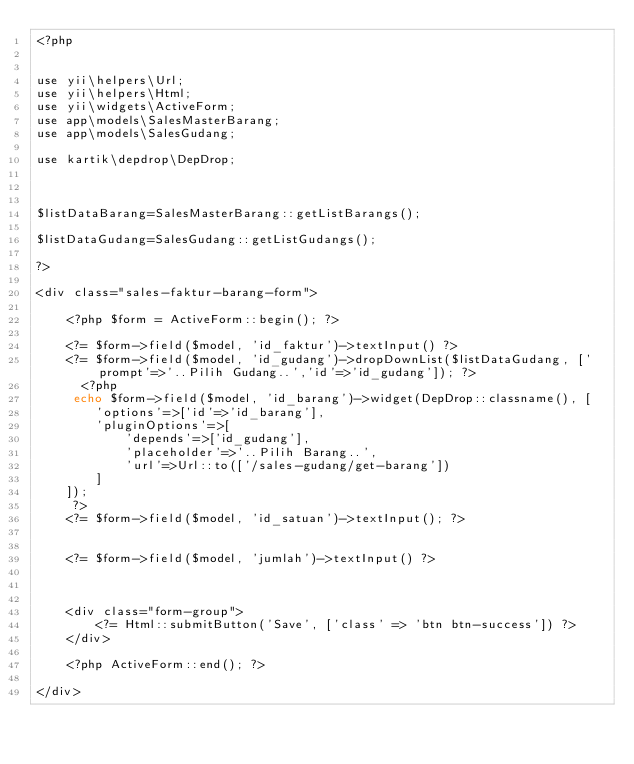<code> <loc_0><loc_0><loc_500><loc_500><_PHP_><?php


use yii\helpers\Url;
use yii\helpers\Html;
use yii\widgets\ActiveForm;
use app\models\SalesMasterBarang;
use app\models\SalesGudang;

use kartik\depdrop\DepDrop;



$listDataBarang=SalesMasterBarang::getListBarangs();

$listDataGudang=SalesGudang::getListGudangs();

?>

<div class="sales-faktur-barang-form">

    <?php $form = ActiveForm::begin(); ?>

    <?= $form->field($model, 'id_faktur')->textInput() ?>
    <?= $form->field($model, 'id_gudang')->dropDownList($listDataGudang, ['prompt'=>'..Pilih Gudang..','id'=>'id_gudang']); ?>
      <?php
     echo $form->field($model, 'id_barang')->widget(DepDrop::classname(), [
        'options'=>['id'=>'id_barang'],
        'pluginOptions'=>[
            'depends'=>['id_gudang'],
            'placeholder'=>'..Pilih Barang..',
            'url'=>Url::to(['/sales-gudang/get-barang'])
        ]
    ]);
     ?>
    <?= $form->field($model, 'id_satuan')->textInput(); ?>


    <?= $form->field($model, 'jumlah')->textInput() ?>



    <div class="form-group">
        <?= Html::submitButton('Save', ['class' => 'btn btn-success']) ?>
    </div>

    <?php ActiveForm::end(); ?>

</div>
</code> 